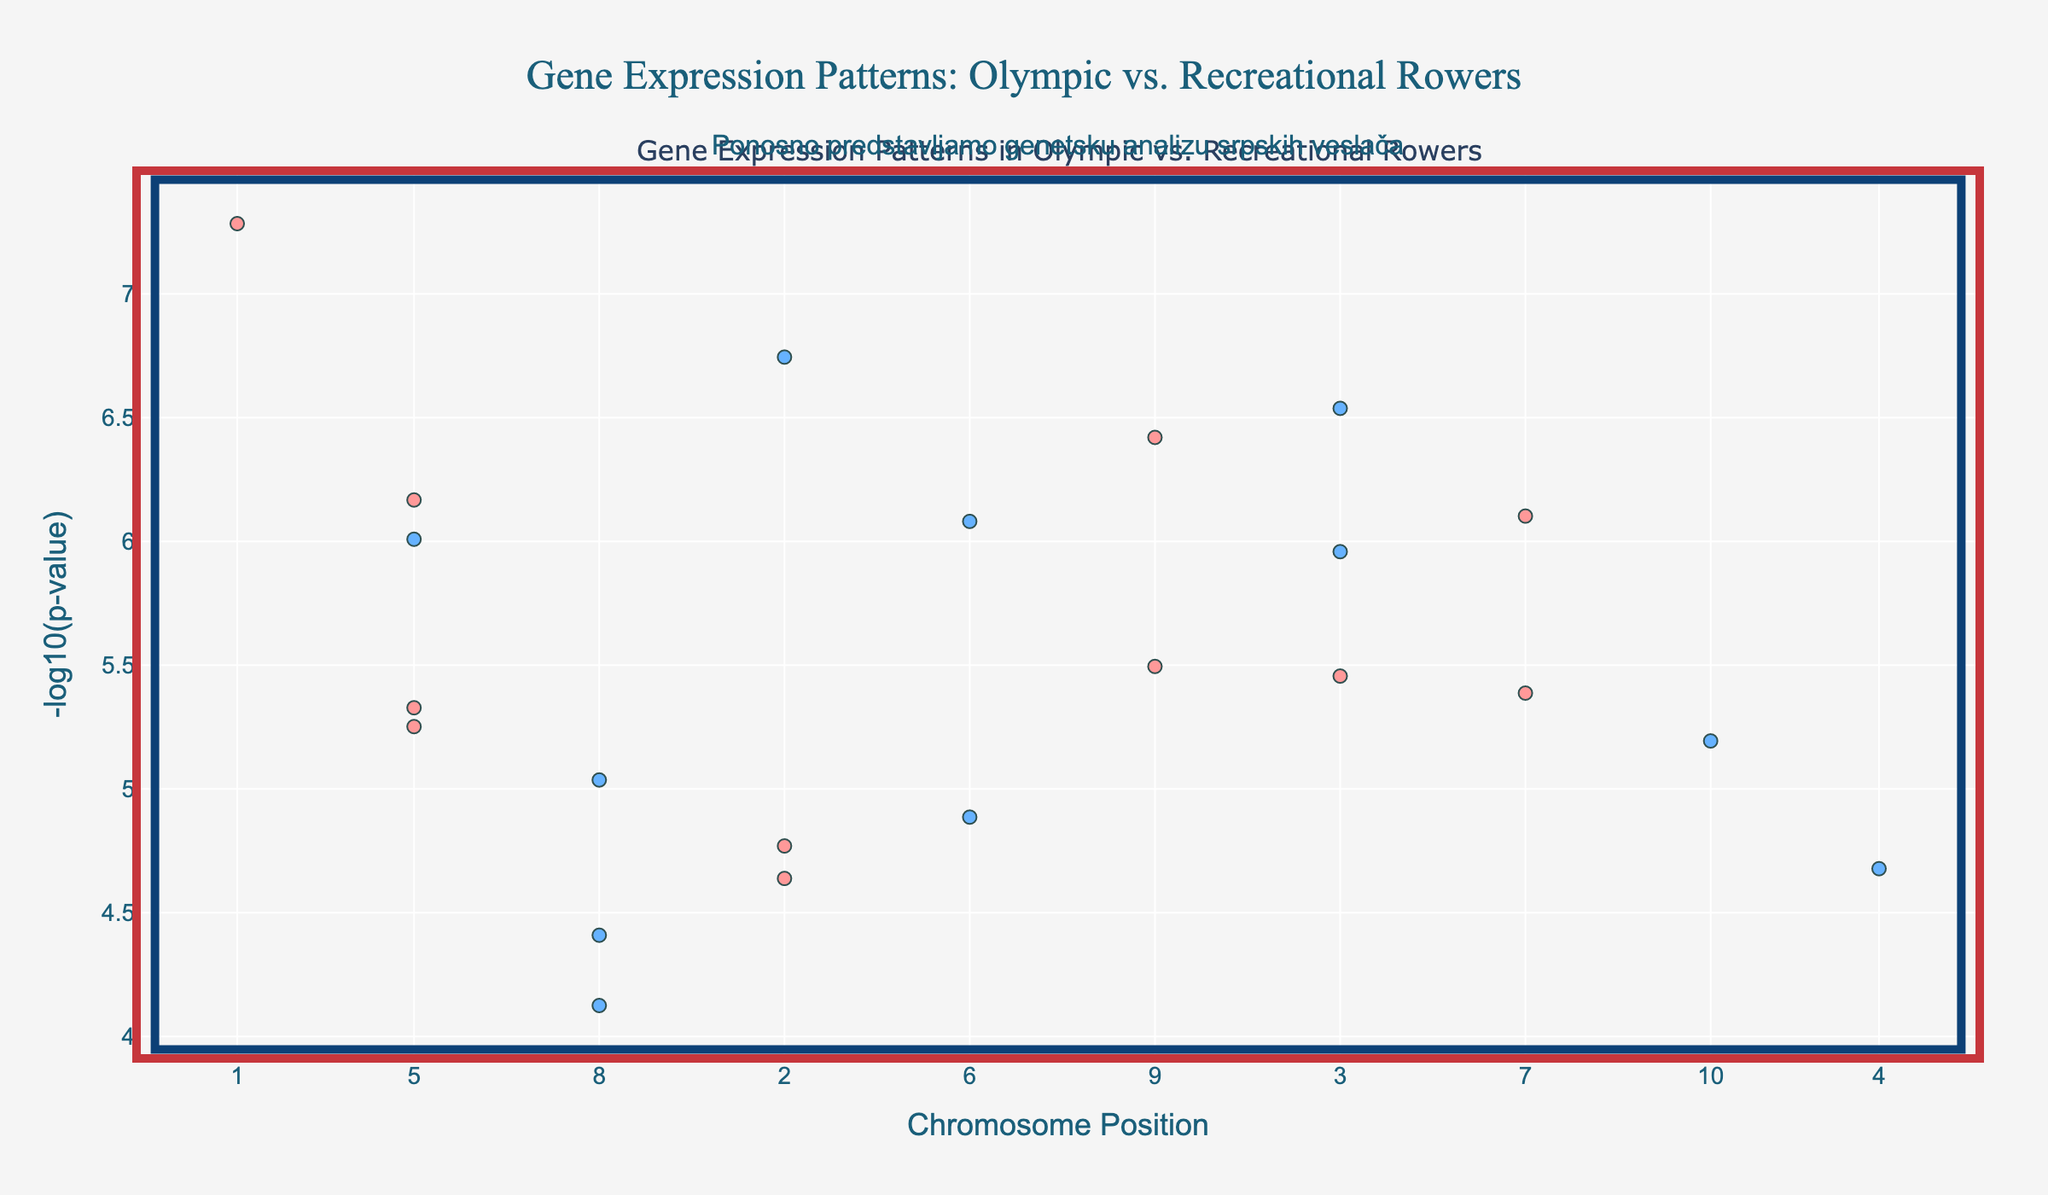What's the title of the plot? The title is located at the top center of the plot. It states: "Gene Expression Patterns: Olympic vs. Recreational Rowers".
Answer: Gene Expression Patterns: Olympic vs. Recreational Rowers Which chromosome has the gene with the lowest p-value? The p-value is represented by the y-axis value of "-log10(p-value)". The gene with the highest y-axis value has the lowest p-value. The highest value corresponds to the gene ACTN3 on Chromosome 1.
Answer: Chromosome 1 How many genes have a -log10(p-value) greater than 7? By inspecting the y-axis, identify the points above the y-value of 7 and count those points. There are three points that meet this criterion.
Answer: 3 Which genes are shown on Chromosome 7 and 14, and what are their -log10(p-values)? Locate Chromosome 7 and Chromosome 14 by their positions on the x-axis and identify the genes. The hover information provides the gene names and their y-axis values. Chromosome 7 has EPOR with a -log10(p-value) of 6.1038, and Chromosome 14 has IL6 with a -log10(p-value) of 6.08.
Answer: EPOR (6.1038), IL6 (6.08) What is the position of the gene MSTN on its chromosome, and what is its -log10(p-value)? By finding the MSTN gene on the hover information, MSTN is located on Chromosome 12 at position 78,000,000 with a -log10(p-value) of 6.5376.
Answer: 78,000,000; 6.5376 Which chromosome has the highest concentration of genes with significant -log10(p-values)? A higher number of points on a chromosome means more significant p-values. Chromosome 1 stands out with multiple high -log10(p-value) points.
Answer: Chromosome 1 What is the y-axis label and what does it represent? The y-axis label is found on the left side of the plot. It states "-log10(p-value)", which represents the negative logarithm (base 10) of the p-value indicating gene significance.
Answer: -log10(p-value) How does the appearance of markers differentiate between alternating chromosomes? The plot uses two different colors to distinguish markers of alternating chromosomes, switching colors between chromosomes to improve clarity.
Answer: Different colors What does the annotation at the top of the plot mean in English? The annotation at the top is written in Serbian and translates to "Proudly presenting the genetic analysis of Serbian rowers".
Answer: Proudly presenting the genetic analysis of Serbian rowers Which genes have a -log10(p-value) of approximately 5.6? By inspecting the y-axis around the value of 5.6 and using the hover information, the genes are PPARGC1A on Chromosome 3 and PPARA on Chromosome 13.
Answer: PPARGC1A (3), PPARA (13) 